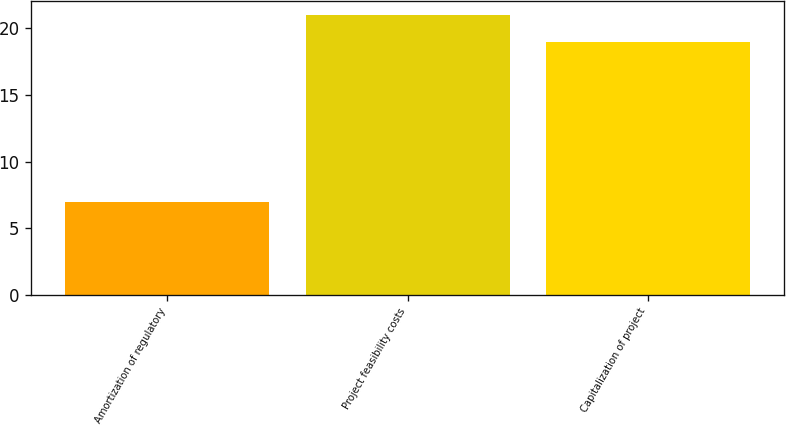Convert chart to OTSL. <chart><loc_0><loc_0><loc_500><loc_500><bar_chart><fcel>Amortization of regulatory<fcel>Project feasibility costs<fcel>Capitalization of project<nl><fcel>7<fcel>21<fcel>19<nl></chart> 